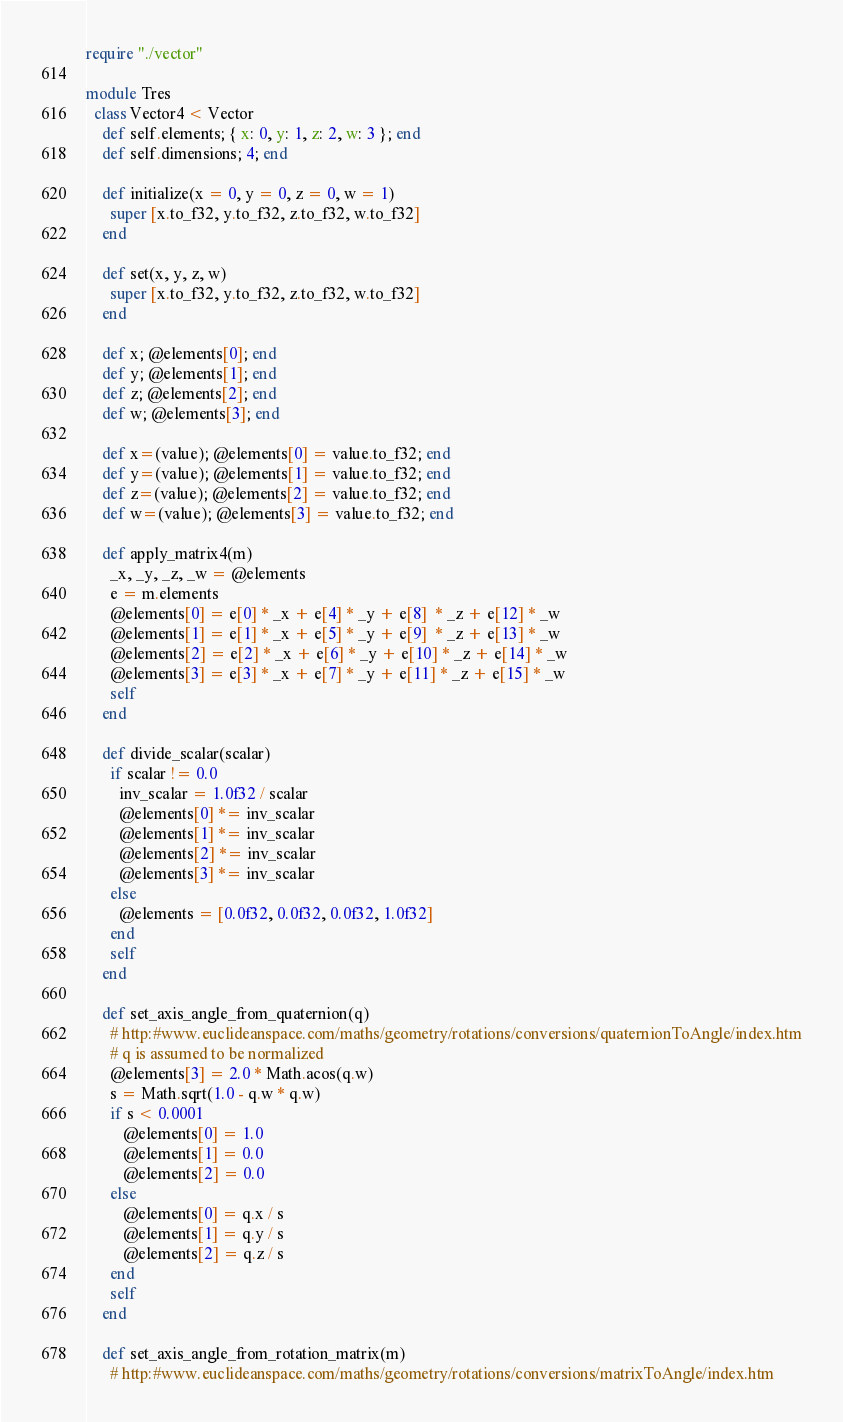Convert code to text. <code><loc_0><loc_0><loc_500><loc_500><_Crystal_>require "./vector"

module Tres
  class Vector4 < Vector
    def self.elements; { x: 0, y: 1, z: 2, w: 3 }; end
    def self.dimensions; 4; end

    def initialize(x = 0, y = 0, z = 0, w = 1)
      super [x.to_f32, y.to_f32, z.to_f32, w.to_f32]
    end

    def set(x, y, z, w)
      super [x.to_f32, y.to_f32, z.to_f32, w.to_f32]
    end

    def x; @elements[0]; end
    def y; @elements[1]; end
    def z; @elements[2]; end
    def w; @elements[3]; end

    def x=(value); @elements[0] = value.to_f32; end
    def y=(value); @elements[1] = value.to_f32; end
    def z=(value); @elements[2] = value.to_f32; end
    def w=(value); @elements[3] = value.to_f32; end

    def apply_matrix4(m)
      _x, _y, _z, _w = @elements
      e = m.elements
      @elements[0] = e[0] * _x + e[4] * _y + e[8]  * _z + e[12] * _w
      @elements[1] = e[1] * _x + e[5] * _y + e[9]  * _z + e[13] * _w
      @elements[2] = e[2] * _x + e[6] * _y + e[10] * _z + e[14] * _w
      @elements[3] = e[3] * _x + e[7] * _y + e[11] * _z + e[15] * _w
      self
    end

    def divide_scalar(scalar)
      if scalar != 0.0
        inv_scalar = 1.0f32 / scalar
        @elements[0] *= inv_scalar
        @elements[1] *= inv_scalar
        @elements[2] *= inv_scalar
        @elements[3] *= inv_scalar
      else
        @elements = [0.0f32, 0.0f32, 0.0f32, 1.0f32]
      end
      self
    end

    def set_axis_angle_from_quaternion(q)
      # http:#www.euclideanspace.com/maths/geometry/rotations/conversions/quaternionToAngle/index.htm
      # q is assumed to be normalized
      @elements[3] = 2.0 * Math.acos(q.w)
      s = Math.sqrt(1.0 - q.w * q.w)
      if s < 0.0001
         @elements[0] = 1.0
         @elements[1] = 0.0
         @elements[2] = 0.0
      else
         @elements[0] = q.x / s
         @elements[1] = q.y / s
         @elements[2] = q.z / s
      end
      self
    end

    def set_axis_angle_from_rotation_matrix(m)
      # http:#www.euclideanspace.com/maths/geometry/rotations/conversions/matrixToAngle/index.htm</code> 